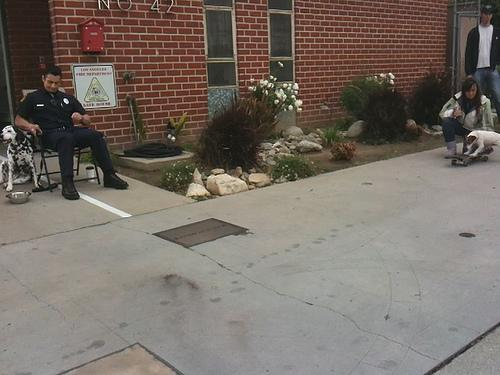Who is the man sitting by the building entrance? police officer 